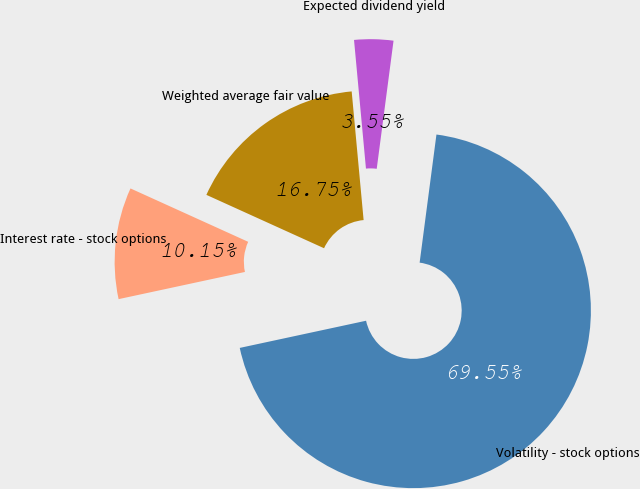Convert chart. <chart><loc_0><loc_0><loc_500><loc_500><pie_chart><fcel>Interest rate - stock options<fcel>Volatility - stock options<fcel>Expected dividend yield<fcel>Weighted average fair value<nl><fcel>10.15%<fcel>69.55%<fcel>3.55%<fcel>16.75%<nl></chart> 